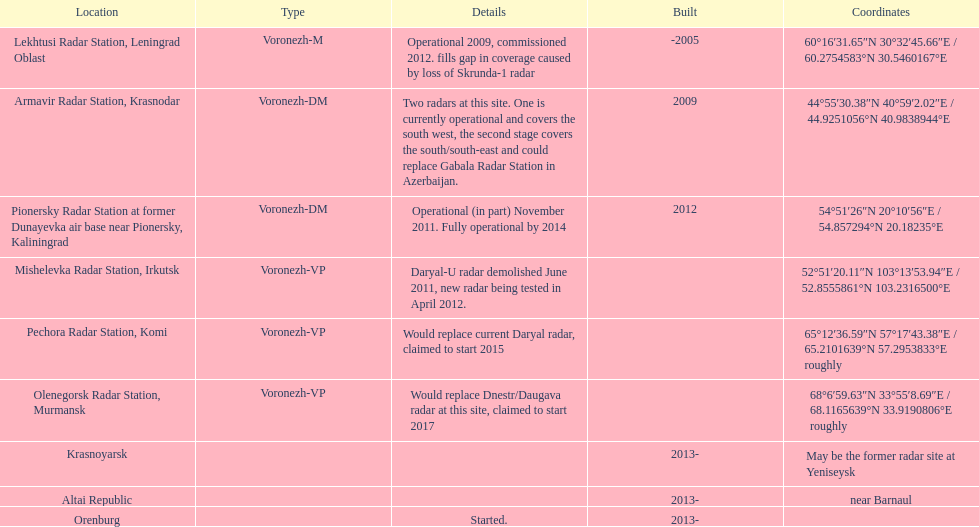What is the only location with a coordination of 60°16&#8242;31.65&#8243;n 30°32&#8242;45.66&#8243;e / 60.2754583°n 30.5460167°e? Lekhtusi Radar Station, Leningrad Oblast. 